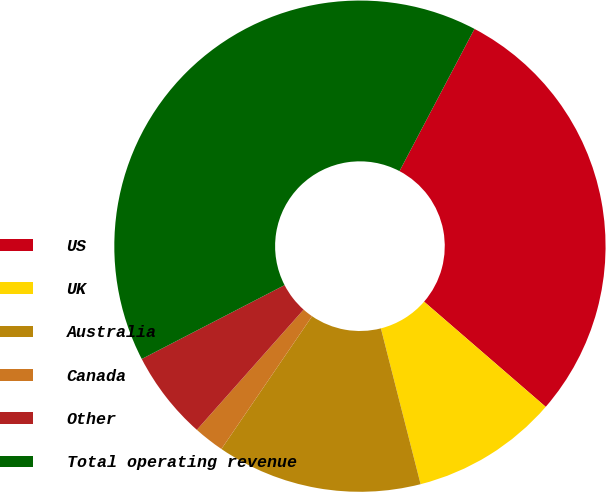<chart> <loc_0><loc_0><loc_500><loc_500><pie_chart><fcel>US<fcel>UK<fcel>Australia<fcel>Canada<fcel>Other<fcel>Total operating revenue<nl><fcel>28.63%<fcel>9.68%<fcel>13.51%<fcel>2.02%<fcel>5.85%<fcel>40.32%<nl></chart> 